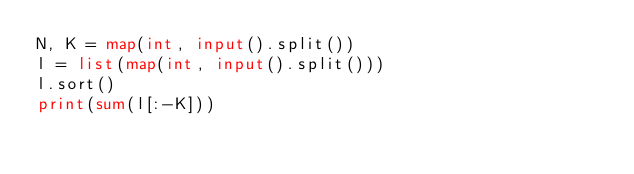Convert code to text. <code><loc_0><loc_0><loc_500><loc_500><_Python_>N, K = map(int, input().split())
l = list(map(int, input().split()))
l.sort()
print(sum(l[:-K]))
</code> 